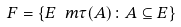Convert formula to latex. <formula><loc_0><loc_0><loc_500><loc_500>\ F = \{ E \ m \tau ( A ) \colon A \subseteq E \}</formula> 